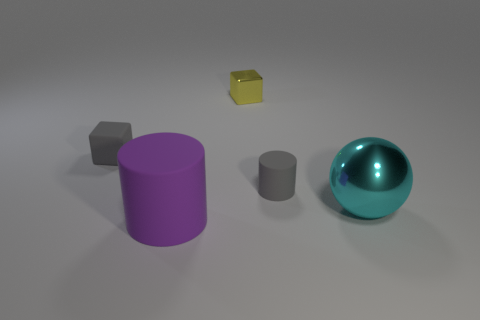Can you describe the size relationship between these objects? Certainly, the purple cylinder is the largest object, followed by the cyan metal sphere which is medium-sized. The two cubes are smaller, with the grey cube being larger than the gold cube. The smallest object is the grey cylinder. 